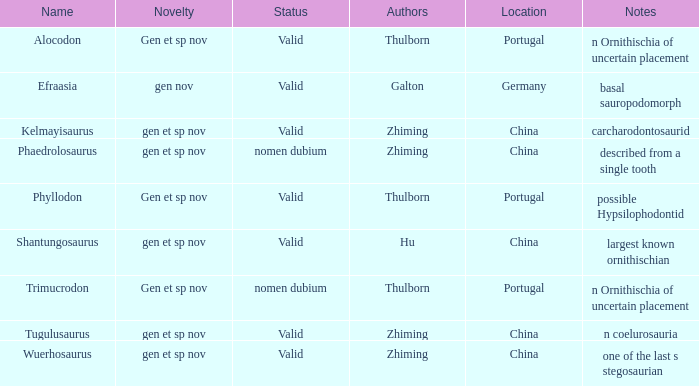What is the distinctive feature of the dinosaur identified by galton? Gen nov. Can you give me this table as a dict? {'header': ['Name', 'Novelty', 'Status', 'Authors', 'Location', 'Notes'], 'rows': [['Alocodon', 'Gen et sp nov', 'Valid', 'Thulborn', 'Portugal', 'n Ornithischia of uncertain placement'], ['Efraasia', 'gen nov', 'Valid', 'Galton', 'Germany', 'basal sauropodomorph'], ['Kelmayisaurus', 'gen et sp nov', 'Valid', 'Zhiming', 'China', 'carcharodontosaurid'], ['Phaedrolosaurus', 'gen et sp nov', 'nomen dubium', 'Zhiming', 'China', 'described from a single tooth'], ['Phyllodon', 'Gen et sp nov', 'Valid', 'Thulborn', 'Portugal', 'possible Hypsilophodontid'], ['Shantungosaurus', 'gen et sp nov', 'Valid', 'Hu', 'China', 'largest known ornithischian'], ['Trimucrodon', 'Gen et sp nov', 'nomen dubium', 'Thulborn', 'Portugal', 'n Ornithischia of uncertain placement'], ['Tugulusaurus', 'gen et sp nov', 'Valid', 'Zhiming', 'China', 'n coelurosauria'], ['Wuerhosaurus', 'gen et sp nov', 'Valid', 'Zhiming', 'China', 'one of the last s stegosaurian']]} 